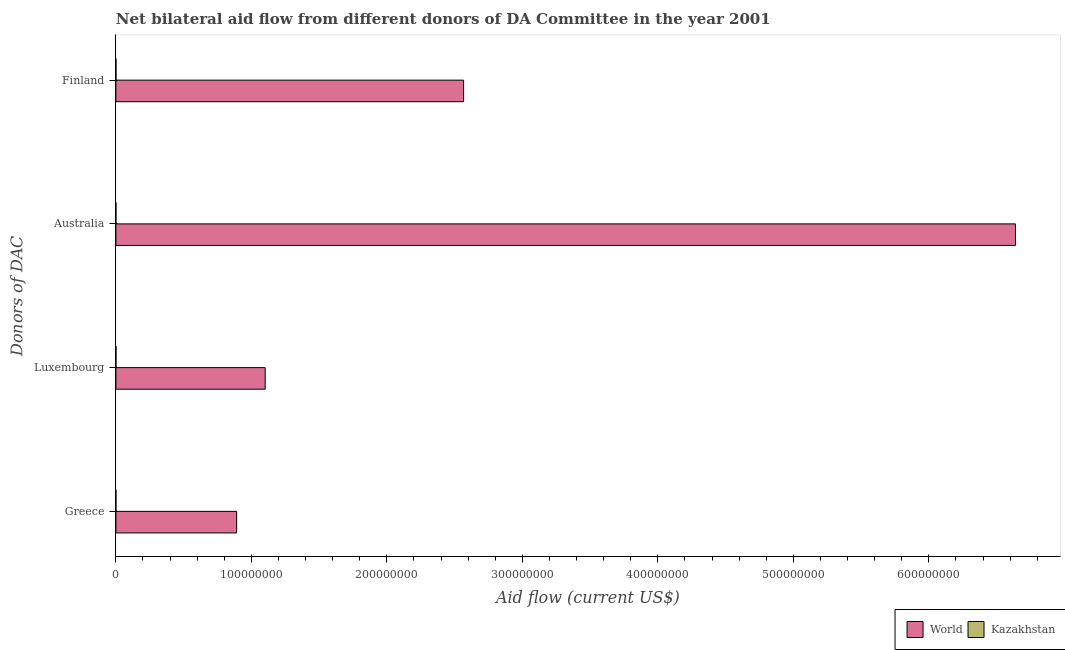How many different coloured bars are there?
Provide a short and direct response. 2. Are the number of bars per tick equal to the number of legend labels?
Offer a very short reply. Yes. Are the number of bars on each tick of the Y-axis equal?
Keep it short and to the point. Yes. How many bars are there on the 3rd tick from the top?
Make the answer very short. 2. How many bars are there on the 1st tick from the bottom?
Provide a short and direct response. 2. What is the label of the 2nd group of bars from the top?
Give a very brief answer. Australia. What is the amount of aid given by australia in Kazakhstan?
Ensure brevity in your answer.  2.00e+04. Across all countries, what is the maximum amount of aid given by greece?
Keep it short and to the point. 8.91e+07. Across all countries, what is the minimum amount of aid given by luxembourg?
Make the answer very short. 3.00e+04. In which country was the amount of aid given by luxembourg maximum?
Keep it short and to the point. World. In which country was the amount of aid given by finland minimum?
Offer a terse response. Kazakhstan. What is the total amount of aid given by australia in the graph?
Provide a succinct answer. 6.64e+08. What is the difference between the amount of aid given by finland in World and that in Kazakhstan?
Make the answer very short. 2.57e+08. What is the difference between the amount of aid given by finland in World and the amount of aid given by greece in Kazakhstan?
Keep it short and to the point. 2.57e+08. What is the average amount of aid given by greece per country?
Make the answer very short. 4.46e+07. What is the difference between the amount of aid given by australia and amount of aid given by luxembourg in World?
Give a very brief answer. 5.54e+08. In how many countries, is the amount of aid given by greece greater than 480000000 US$?
Keep it short and to the point. 0. What is the ratio of the amount of aid given by finland in World to that in Kazakhstan?
Make the answer very short. 5132.6. Is the amount of aid given by greece in Kazakhstan less than that in World?
Your answer should be compact. Yes. Is the difference between the amount of aid given by finland in World and Kazakhstan greater than the difference between the amount of aid given by australia in World and Kazakhstan?
Offer a terse response. No. What is the difference between the highest and the second highest amount of aid given by australia?
Provide a short and direct response. 6.64e+08. What is the difference between the highest and the lowest amount of aid given by australia?
Offer a terse response. 6.64e+08. In how many countries, is the amount of aid given by greece greater than the average amount of aid given by greece taken over all countries?
Your response must be concise. 1. Is the sum of the amount of aid given by finland in World and Kazakhstan greater than the maximum amount of aid given by luxembourg across all countries?
Provide a succinct answer. Yes. What does the 2nd bar from the top in Finland represents?
Offer a terse response. World. What does the 1st bar from the bottom in Luxembourg represents?
Provide a short and direct response. World. Is it the case that in every country, the sum of the amount of aid given by greece and amount of aid given by luxembourg is greater than the amount of aid given by australia?
Offer a very short reply. No. How many bars are there?
Provide a succinct answer. 8. How many countries are there in the graph?
Make the answer very short. 2. What is the difference between two consecutive major ticks on the X-axis?
Keep it short and to the point. 1.00e+08. Does the graph contain grids?
Provide a short and direct response. No. Where does the legend appear in the graph?
Your answer should be very brief. Bottom right. How are the legend labels stacked?
Offer a very short reply. Horizontal. What is the title of the graph?
Your response must be concise. Net bilateral aid flow from different donors of DA Committee in the year 2001. What is the label or title of the Y-axis?
Keep it short and to the point. Donors of DAC. What is the Aid flow (current US$) in World in Greece?
Your answer should be compact. 8.91e+07. What is the Aid flow (current US$) of Kazakhstan in Greece?
Offer a very short reply. 10000. What is the Aid flow (current US$) in World in Luxembourg?
Your response must be concise. 1.10e+08. What is the Aid flow (current US$) of Kazakhstan in Luxembourg?
Your answer should be very brief. 3.00e+04. What is the Aid flow (current US$) of World in Australia?
Your answer should be compact. 6.64e+08. What is the Aid flow (current US$) in World in Finland?
Provide a succinct answer. 2.57e+08. Across all Donors of DAC, what is the maximum Aid flow (current US$) in World?
Keep it short and to the point. 6.64e+08. Across all Donors of DAC, what is the maximum Aid flow (current US$) of Kazakhstan?
Keep it short and to the point. 5.00e+04. Across all Donors of DAC, what is the minimum Aid flow (current US$) in World?
Ensure brevity in your answer.  8.91e+07. Across all Donors of DAC, what is the minimum Aid flow (current US$) in Kazakhstan?
Keep it short and to the point. 10000. What is the total Aid flow (current US$) of World in the graph?
Your response must be concise. 1.12e+09. What is the total Aid flow (current US$) of Kazakhstan in the graph?
Ensure brevity in your answer.  1.10e+05. What is the difference between the Aid flow (current US$) of World in Greece and that in Luxembourg?
Make the answer very short. -2.11e+07. What is the difference between the Aid flow (current US$) in Kazakhstan in Greece and that in Luxembourg?
Offer a terse response. -2.00e+04. What is the difference between the Aid flow (current US$) of World in Greece and that in Australia?
Offer a very short reply. -5.75e+08. What is the difference between the Aid flow (current US$) in Kazakhstan in Greece and that in Australia?
Your answer should be very brief. -10000. What is the difference between the Aid flow (current US$) of World in Greece and that in Finland?
Offer a very short reply. -1.68e+08. What is the difference between the Aid flow (current US$) of World in Luxembourg and that in Australia?
Provide a short and direct response. -5.54e+08. What is the difference between the Aid flow (current US$) in World in Luxembourg and that in Finland?
Offer a terse response. -1.46e+08. What is the difference between the Aid flow (current US$) of World in Australia and that in Finland?
Give a very brief answer. 4.07e+08. What is the difference between the Aid flow (current US$) of World in Greece and the Aid flow (current US$) of Kazakhstan in Luxembourg?
Your answer should be compact. 8.91e+07. What is the difference between the Aid flow (current US$) of World in Greece and the Aid flow (current US$) of Kazakhstan in Australia?
Provide a short and direct response. 8.91e+07. What is the difference between the Aid flow (current US$) in World in Greece and the Aid flow (current US$) in Kazakhstan in Finland?
Provide a succinct answer. 8.91e+07. What is the difference between the Aid flow (current US$) of World in Luxembourg and the Aid flow (current US$) of Kazakhstan in Australia?
Give a very brief answer. 1.10e+08. What is the difference between the Aid flow (current US$) of World in Luxembourg and the Aid flow (current US$) of Kazakhstan in Finland?
Give a very brief answer. 1.10e+08. What is the difference between the Aid flow (current US$) in World in Australia and the Aid flow (current US$) in Kazakhstan in Finland?
Your answer should be very brief. 6.64e+08. What is the average Aid flow (current US$) in World per Donors of DAC?
Offer a very short reply. 2.80e+08. What is the average Aid flow (current US$) of Kazakhstan per Donors of DAC?
Provide a short and direct response. 2.75e+04. What is the difference between the Aid flow (current US$) of World and Aid flow (current US$) of Kazakhstan in Greece?
Your answer should be compact. 8.91e+07. What is the difference between the Aid flow (current US$) in World and Aid flow (current US$) in Kazakhstan in Luxembourg?
Your response must be concise. 1.10e+08. What is the difference between the Aid flow (current US$) in World and Aid flow (current US$) in Kazakhstan in Australia?
Your answer should be compact. 6.64e+08. What is the difference between the Aid flow (current US$) in World and Aid flow (current US$) in Kazakhstan in Finland?
Make the answer very short. 2.57e+08. What is the ratio of the Aid flow (current US$) of World in Greece to that in Luxembourg?
Ensure brevity in your answer.  0.81. What is the ratio of the Aid flow (current US$) in World in Greece to that in Australia?
Keep it short and to the point. 0.13. What is the ratio of the Aid flow (current US$) in World in Greece to that in Finland?
Make the answer very short. 0.35. What is the ratio of the Aid flow (current US$) in Kazakhstan in Greece to that in Finland?
Give a very brief answer. 0.2. What is the ratio of the Aid flow (current US$) in World in Luxembourg to that in Australia?
Your answer should be compact. 0.17. What is the ratio of the Aid flow (current US$) of Kazakhstan in Luxembourg to that in Australia?
Offer a terse response. 1.5. What is the ratio of the Aid flow (current US$) in World in Luxembourg to that in Finland?
Provide a succinct answer. 0.43. What is the ratio of the Aid flow (current US$) in World in Australia to that in Finland?
Ensure brevity in your answer.  2.59. What is the difference between the highest and the second highest Aid flow (current US$) of World?
Give a very brief answer. 4.07e+08. What is the difference between the highest and the lowest Aid flow (current US$) of World?
Your answer should be compact. 5.75e+08. 